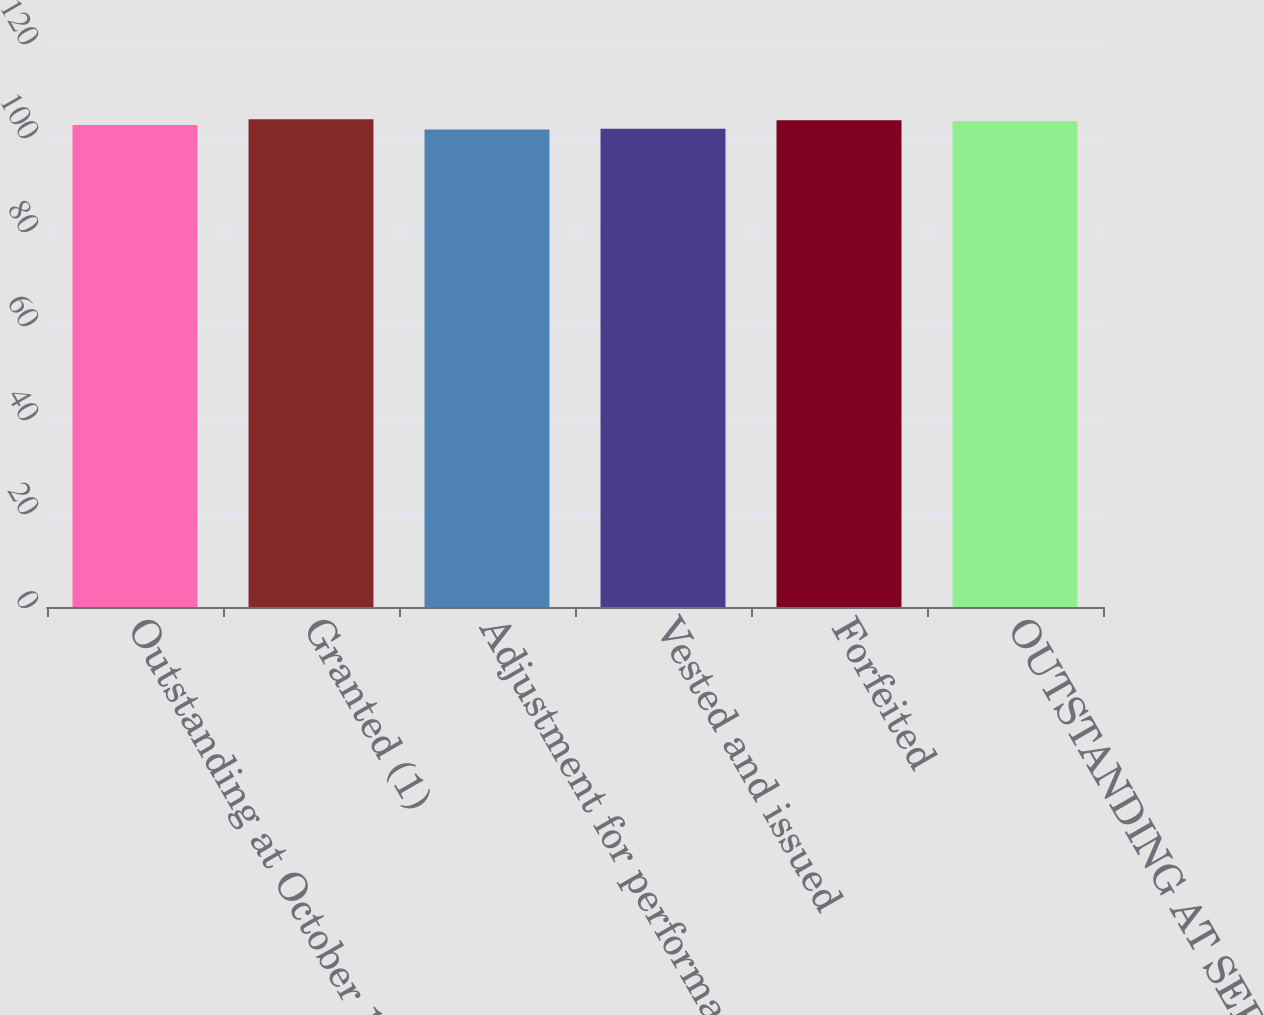Convert chart to OTSL. <chart><loc_0><loc_0><loc_500><loc_500><bar_chart><fcel>Outstanding at October 1 2014<fcel>Granted (1)<fcel>Adjustment for performance<fcel>Vested and issued<fcel>Forfeited<fcel>OUTSTANDING AT SEPTEMBER 30<nl><fcel>102.54<fcel>103.77<fcel>101.57<fcel>101.78<fcel>103.56<fcel>103.33<nl></chart> 